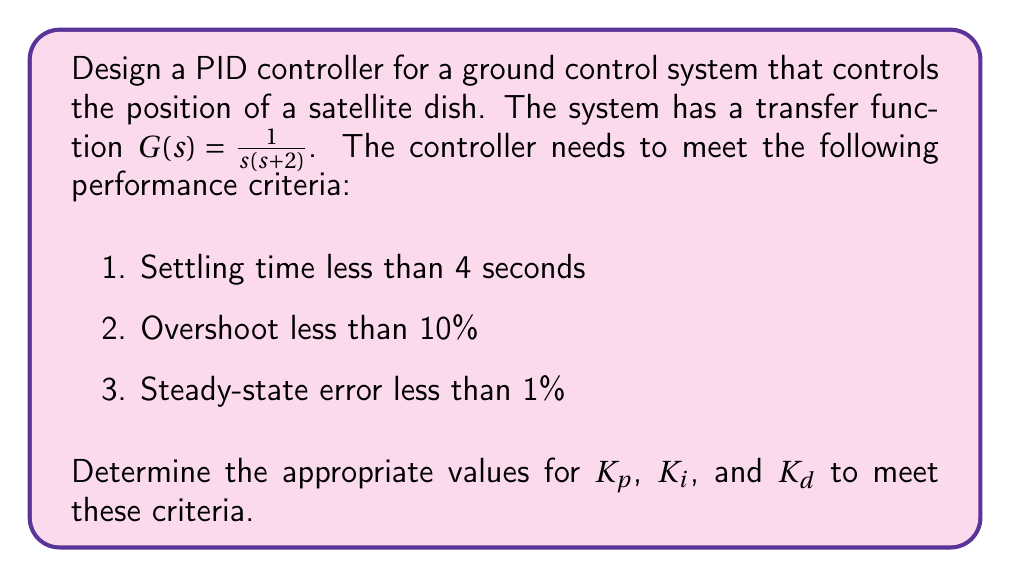Can you answer this question? To design a PID controller that meets the given performance criteria, we'll follow these steps:

1. Determine the required damping ratio ($\zeta$) and natural frequency ($\omega_n$) based on the settling time and overshoot requirements.

2. Calculate the controller parameters $K_p$, $K_i$, and $K_d$.

3. Verify if the steady-state error requirement is met.

Step 1: Determining $\zeta$ and $\omega_n$

For overshoot less than 10%:
$$\zeta = \sqrt{\frac{\ln^2(0.1)}{{\pi^2 + \ln^2(0.1)}}} \approx 0.591$$

For settling time less than 4 seconds (using 2% criterion):
$$T_s = \frac{4}{\zeta\omega_n} < 4$$
$$\omega_n > \frac{4}{\zeta T_s} = \frac{4}{0.591 \cdot 4} \approx 1.69 \text{ rad/s}$$

Let's choose $\omega_n = 2 \text{ rad/s}$ to ensure we meet the settling time requirement.

Step 2: Calculating controller parameters

The characteristic equation of the closed-loop system with a PID controller is:
$$s^3 + (2+K_d)s^2 + K_ps + K_i = 0$$

Comparing this with the standard second-order characteristic equation:
$$s^2 + 2\zeta\omega_ns + \omega_n^2 = 0$$

We can derive:
$$K_d = 2\zeta\omega_n - 2 = 2(0.591)(2) - 2 = 0.364$$
$$K_p = \omega_n^2 = 2^2 = 4$$
$$K_i = \omega_n^2(2+K_d) = 4(2+0.364) = 9.456$$

Step 3: Verifying steady-state error

The steady-state error for a step input is given by:
$$e_{ss} = \frac{1}{1 + K_p/2 + K_i/0}$$

Substituting the values:
$$e_{ss} = \frac{1}{1 + 4/2 + \infty} = 0$$

This meets the requirement of steady-state error less than 1%.

Therefore, the PID controller parameters that meet all the given criteria are:
$K_p = 4$, $K_i = 9.456$, and $K_d = 0.364$.
Answer: $K_p = 4$, $K_i = 9.456$, $K_d = 0.364$ 